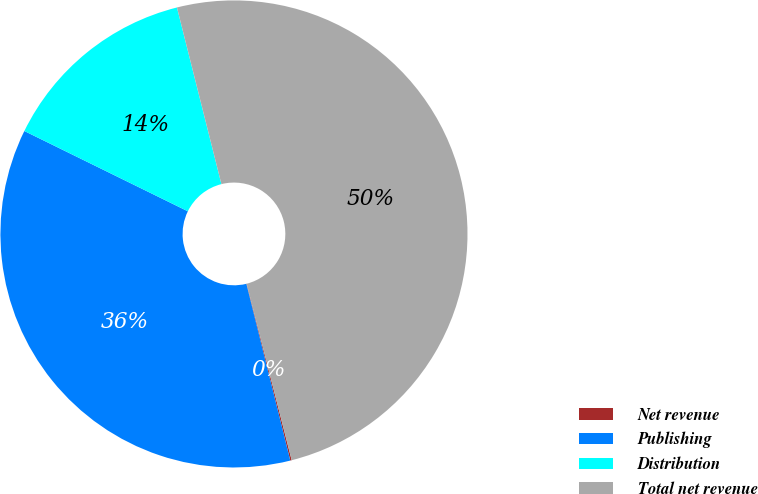Convert chart. <chart><loc_0><loc_0><loc_500><loc_500><pie_chart><fcel>Net revenue<fcel>Publishing<fcel>Distribution<fcel>Total net revenue<nl><fcel>0.1%<fcel>36.14%<fcel>13.81%<fcel>49.95%<nl></chart> 